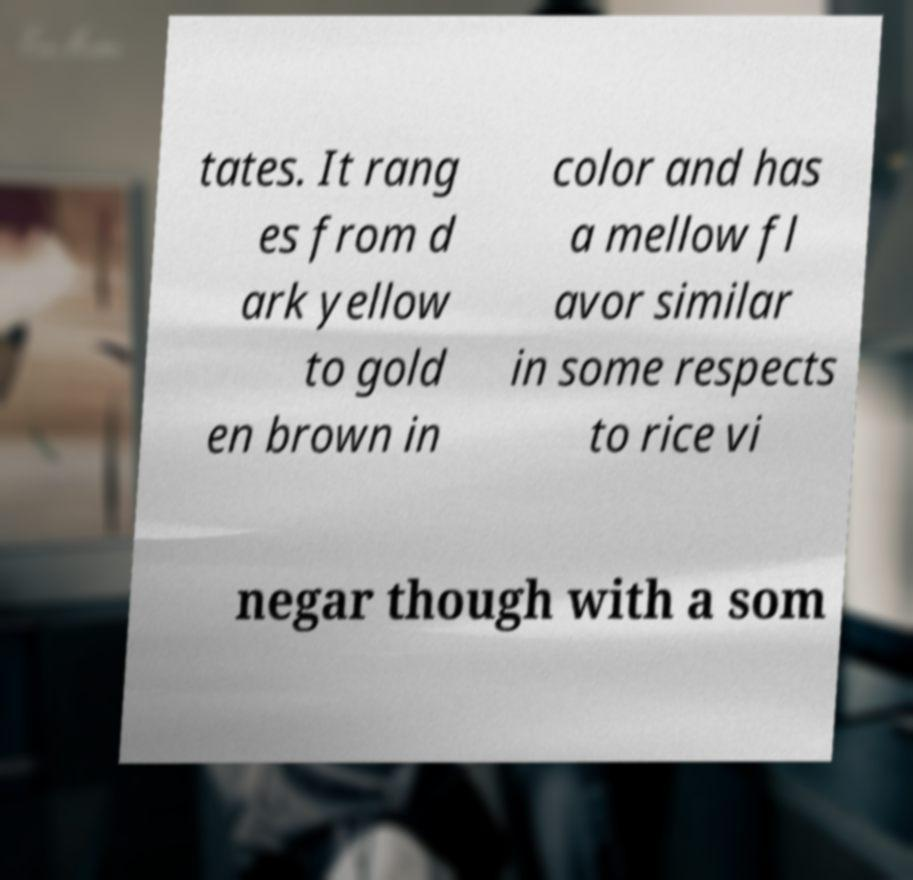Could you extract and type out the text from this image? tates. It rang es from d ark yellow to gold en brown in color and has a mellow fl avor similar in some respects to rice vi negar though with a som 